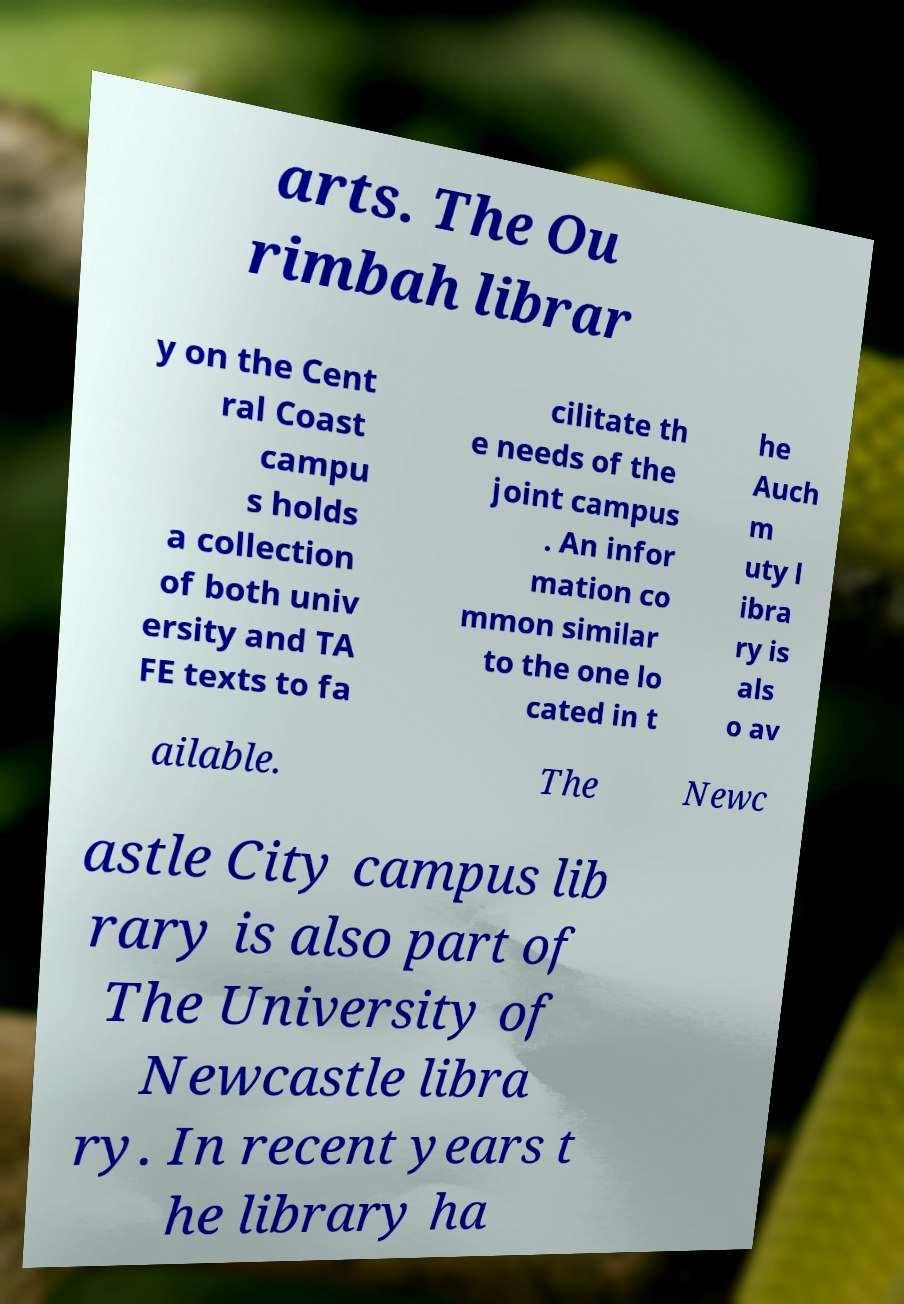Please read and relay the text visible in this image. What does it say? arts. The Ou rimbah librar y on the Cent ral Coast campu s holds a collection of both univ ersity and TA FE texts to fa cilitate th e needs of the joint campus . An infor mation co mmon similar to the one lo cated in t he Auch m uty l ibra ry is als o av ailable. The Newc astle City campus lib rary is also part of The University of Newcastle libra ry. In recent years t he library ha 